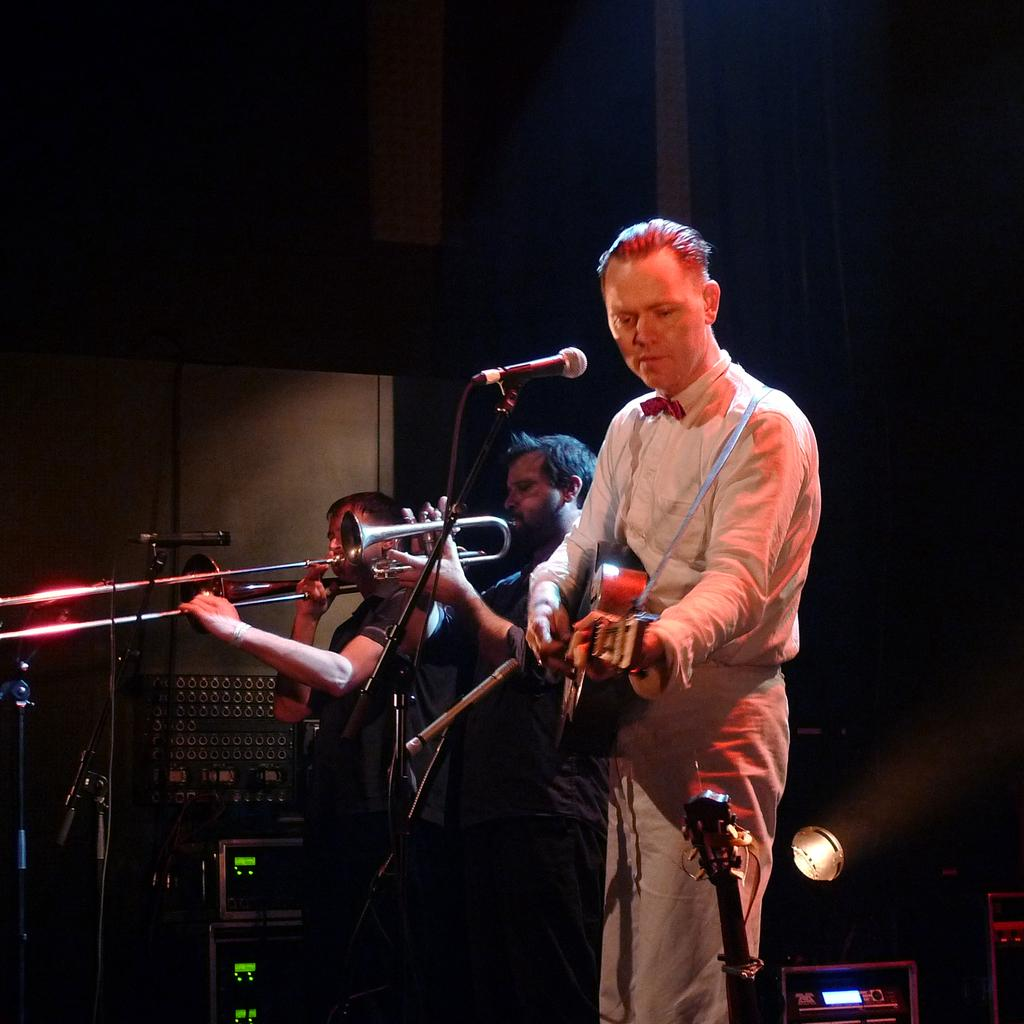What are the people in the image doing? The people in the image are playing musical instruments. What object is present in front of the people? There is a microphone in front of the people. What type of oven can be seen in the background of the image? There is no oven present in the image. What liquid is being used by the people while playing their instruments? The people are not using any liquid while playing their instruments. 